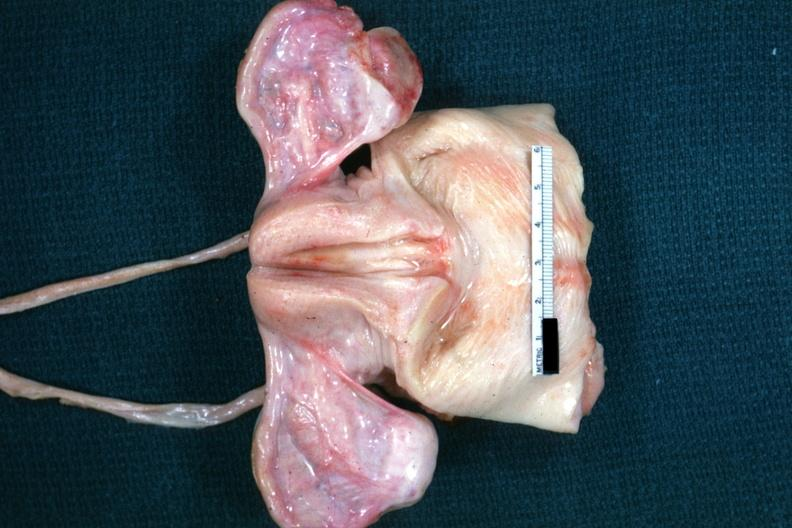does this image show not truly normal ovaries are non functional in this case of vacant sella but externally i can see nothing?
Answer the question using a single word or phrase. Yes 